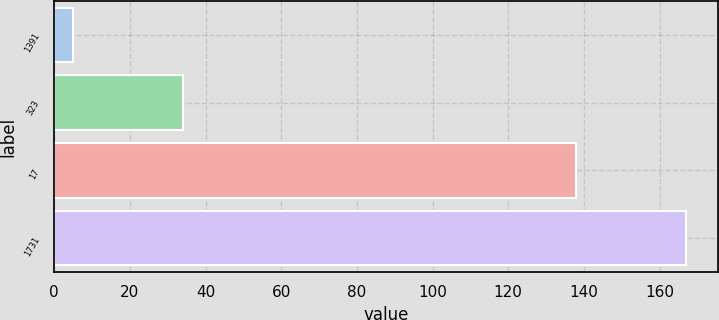<chart> <loc_0><loc_0><loc_500><loc_500><bar_chart><fcel>1391<fcel>323<fcel>17<fcel>1731<nl><fcel>5<fcel>34<fcel>138<fcel>167<nl></chart> 